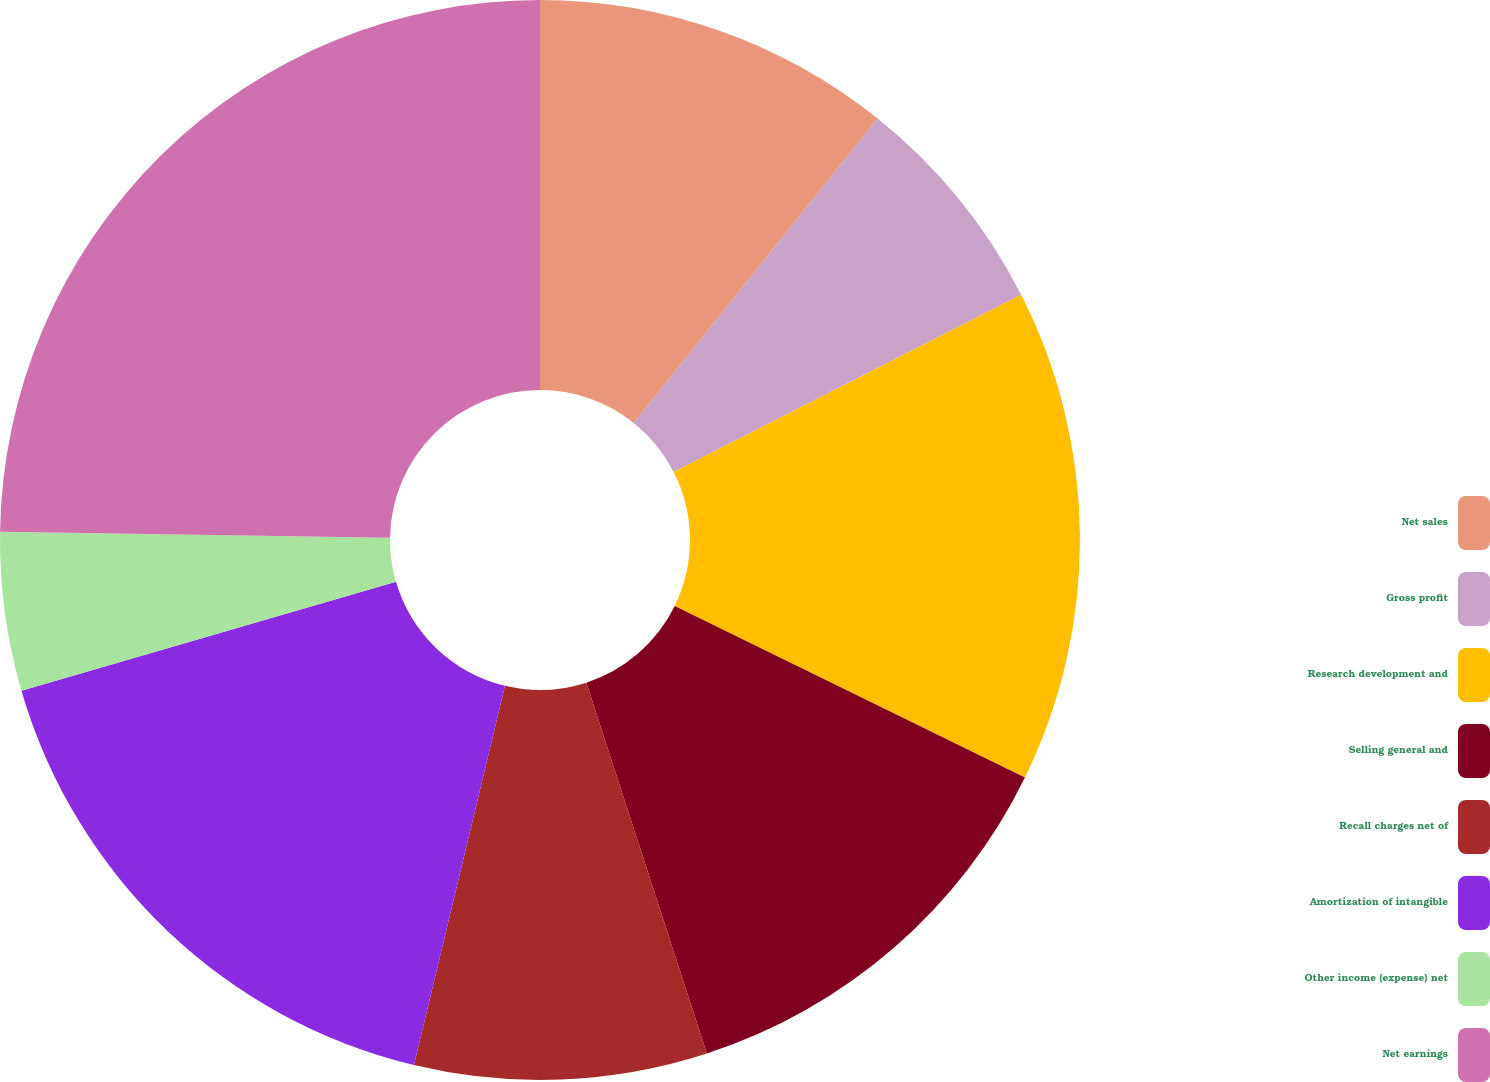Convert chart to OTSL. <chart><loc_0><loc_0><loc_500><loc_500><pie_chart><fcel>Net sales<fcel>Gross profit<fcel>Research development and<fcel>Selling general and<fcel>Recall charges net of<fcel>Amortization of intangible<fcel>Other income (expense) net<fcel>Net earnings<nl><fcel>10.75%<fcel>6.75%<fcel>14.75%<fcel>12.75%<fcel>8.75%<fcel>16.75%<fcel>4.74%<fcel>24.76%<nl></chart> 